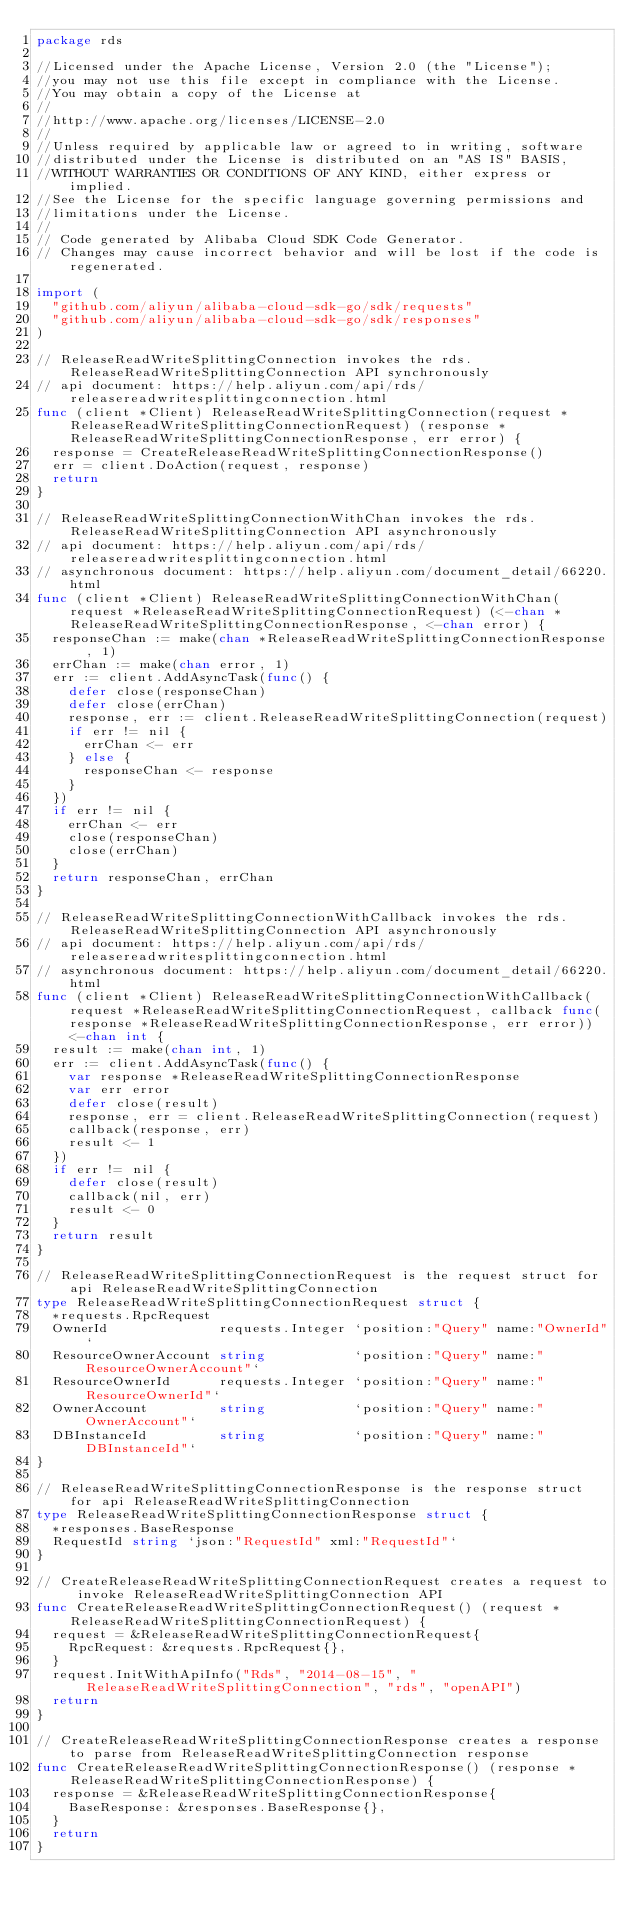<code> <loc_0><loc_0><loc_500><loc_500><_Go_>package rds

//Licensed under the Apache License, Version 2.0 (the "License");
//you may not use this file except in compliance with the License.
//You may obtain a copy of the License at
//
//http://www.apache.org/licenses/LICENSE-2.0
//
//Unless required by applicable law or agreed to in writing, software
//distributed under the License is distributed on an "AS IS" BASIS,
//WITHOUT WARRANTIES OR CONDITIONS OF ANY KIND, either express or implied.
//See the License for the specific language governing permissions and
//limitations under the License.
//
// Code generated by Alibaba Cloud SDK Code Generator.
// Changes may cause incorrect behavior and will be lost if the code is regenerated.

import (
	"github.com/aliyun/alibaba-cloud-sdk-go/sdk/requests"
	"github.com/aliyun/alibaba-cloud-sdk-go/sdk/responses"
)

// ReleaseReadWriteSplittingConnection invokes the rds.ReleaseReadWriteSplittingConnection API synchronously
// api document: https://help.aliyun.com/api/rds/releasereadwritesplittingconnection.html
func (client *Client) ReleaseReadWriteSplittingConnection(request *ReleaseReadWriteSplittingConnectionRequest) (response *ReleaseReadWriteSplittingConnectionResponse, err error) {
	response = CreateReleaseReadWriteSplittingConnectionResponse()
	err = client.DoAction(request, response)
	return
}

// ReleaseReadWriteSplittingConnectionWithChan invokes the rds.ReleaseReadWriteSplittingConnection API asynchronously
// api document: https://help.aliyun.com/api/rds/releasereadwritesplittingconnection.html
// asynchronous document: https://help.aliyun.com/document_detail/66220.html
func (client *Client) ReleaseReadWriteSplittingConnectionWithChan(request *ReleaseReadWriteSplittingConnectionRequest) (<-chan *ReleaseReadWriteSplittingConnectionResponse, <-chan error) {
	responseChan := make(chan *ReleaseReadWriteSplittingConnectionResponse, 1)
	errChan := make(chan error, 1)
	err := client.AddAsyncTask(func() {
		defer close(responseChan)
		defer close(errChan)
		response, err := client.ReleaseReadWriteSplittingConnection(request)
		if err != nil {
			errChan <- err
		} else {
			responseChan <- response
		}
	})
	if err != nil {
		errChan <- err
		close(responseChan)
		close(errChan)
	}
	return responseChan, errChan
}

// ReleaseReadWriteSplittingConnectionWithCallback invokes the rds.ReleaseReadWriteSplittingConnection API asynchronously
// api document: https://help.aliyun.com/api/rds/releasereadwritesplittingconnection.html
// asynchronous document: https://help.aliyun.com/document_detail/66220.html
func (client *Client) ReleaseReadWriteSplittingConnectionWithCallback(request *ReleaseReadWriteSplittingConnectionRequest, callback func(response *ReleaseReadWriteSplittingConnectionResponse, err error)) <-chan int {
	result := make(chan int, 1)
	err := client.AddAsyncTask(func() {
		var response *ReleaseReadWriteSplittingConnectionResponse
		var err error
		defer close(result)
		response, err = client.ReleaseReadWriteSplittingConnection(request)
		callback(response, err)
		result <- 1
	})
	if err != nil {
		defer close(result)
		callback(nil, err)
		result <- 0
	}
	return result
}

// ReleaseReadWriteSplittingConnectionRequest is the request struct for api ReleaseReadWriteSplittingConnection
type ReleaseReadWriteSplittingConnectionRequest struct {
	*requests.RpcRequest
	OwnerId              requests.Integer `position:"Query" name:"OwnerId"`
	ResourceOwnerAccount string           `position:"Query" name:"ResourceOwnerAccount"`
	ResourceOwnerId      requests.Integer `position:"Query" name:"ResourceOwnerId"`
	OwnerAccount         string           `position:"Query" name:"OwnerAccount"`
	DBInstanceId         string           `position:"Query" name:"DBInstanceId"`
}

// ReleaseReadWriteSplittingConnectionResponse is the response struct for api ReleaseReadWriteSplittingConnection
type ReleaseReadWriteSplittingConnectionResponse struct {
	*responses.BaseResponse
	RequestId string `json:"RequestId" xml:"RequestId"`
}

// CreateReleaseReadWriteSplittingConnectionRequest creates a request to invoke ReleaseReadWriteSplittingConnection API
func CreateReleaseReadWriteSplittingConnectionRequest() (request *ReleaseReadWriteSplittingConnectionRequest) {
	request = &ReleaseReadWriteSplittingConnectionRequest{
		RpcRequest: &requests.RpcRequest{},
	}
	request.InitWithApiInfo("Rds", "2014-08-15", "ReleaseReadWriteSplittingConnection", "rds", "openAPI")
	return
}

// CreateReleaseReadWriteSplittingConnectionResponse creates a response to parse from ReleaseReadWriteSplittingConnection response
func CreateReleaseReadWriteSplittingConnectionResponse() (response *ReleaseReadWriteSplittingConnectionResponse) {
	response = &ReleaseReadWriteSplittingConnectionResponse{
		BaseResponse: &responses.BaseResponse{},
	}
	return
}
</code> 